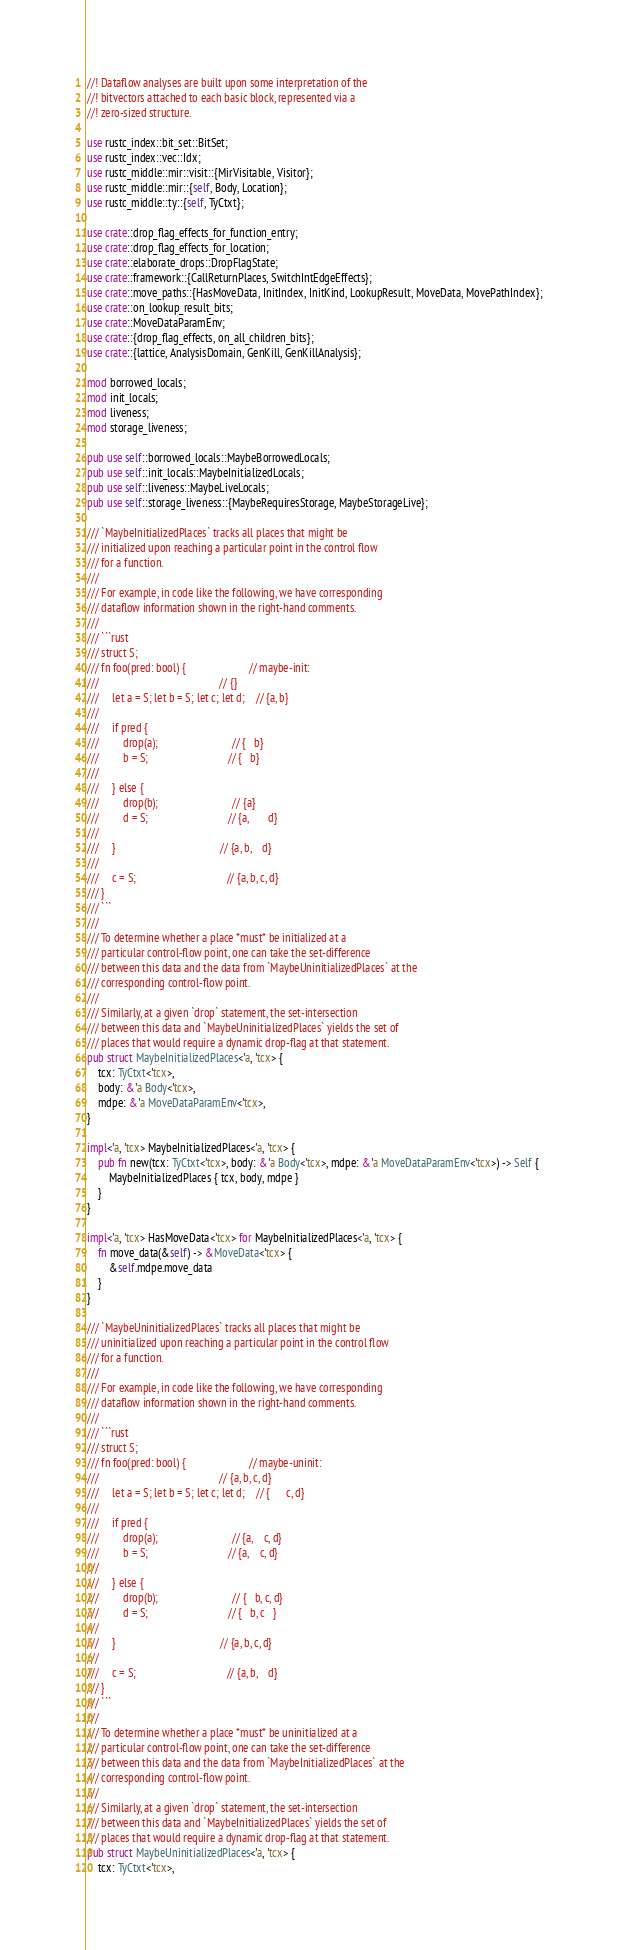<code> <loc_0><loc_0><loc_500><loc_500><_Rust_>//! Dataflow analyses are built upon some interpretation of the
//! bitvectors attached to each basic block, represented via a
//! zero-sized structure.

use rustc_index::bit_set::BitSet;
use rustc_index::vec::Idx;
use rustc_middle::mir::visit::{MirVisitable, Visitor};
use rustc_middle::mir::{self, Body, Location};
use rustc_middle::ty::{self, TyCtxt};

use crate::drop_flag_effects_for_function_entry;
use crate::drop_flag_effects_for_location;
use crate::elaborate_drops::DropFlagState;
use crate::framework::{CallReturnPlaces, SwitchIntEdgeEffects};
use crate::move_paths::{HasMoveData, InitIndex, InitKind, LookupResult, MoveData, MovePathIndex};
use crate::on_lookup_result_bits;
use crate::MoveDataParamEnv;
use crate::{drop_flag_effects, on_all_children_bits};
use crate::{lattice, AnalysisDomain, GenKill, GenKillAnalysis};

mod borrowed_locals;
mod init_locals;
mod liveness;
mod storage_liveness;

pub use self::borrowed_locals::MaybeBorrowedLocals;
pub use self::init_locals::MaybeInitializedLocals;
pub use self::liveness::MaybeLiveLocals;
pub use self::storage_liveness::{MaybeRequiresStorage, MaybeStorageLive};

/// `MaybeInitializedPlaces` tracks all places that might be
/// initialized upon reaching a particular point in the control flow
/// for a function.
///
/// For example, in code like the following, we have corresponding
/// dataflow information shown in the right-hand comments.
///
/// ```rust
/// struct S;
/// fn foo(pred: bool) {                       // maybe-init:
///                                            // {}
///     let a = S; let b = S; let c; let d;    // {a, b}
///
///     if pred {
///         drop(a);                           // {   b}
///         b = S;                             // {   b}
///
///     } else {
///         drop(b);                           // {a}
///         d = S;                             // {a,       d}
///
///     }                                      // {a, b,    d}
///
///     c = S;                                 // {a, b, c, d}
/// }
/// ```
///
/// To determine whether a place *must* be initialized at a
/// particular control-flow point, one can take the set-difference
/// between this data and the data from `MaybeUninitializedPlaces` at the
/// corresponding control-flow point.
///
/// Similarly, at a given `drop` statement, the set-intersection
/// between this data and `MaybeUninitializedPlaces` yields the set of
/// places that would require a dynamic drop-flag at that statement.
pub struct MaybeInitializedPlaces<'a, 'tcx> {
    tcx: TyCtxt<'tcx>,
    body: &'a Body<'tcx>,
    mdpe: &'a MoveDataParamEnv<'tcx>,
}

impl<'a, 'tcx> MaybeInitializedPlaces<'a, 'tcx> {
    pub fn new(tcx: TyCtxt<'tcx>, body: &'a Body<'tcx>, mdpe: &'a MoveDataParamEnv<'tcx>) -> Self {
        MaybeInitializedPlaces { tcx, body, mdpe }
    }
}

impl<'a, 'tcx> HasMoveData<'tcx> for MaybeInitializedPlaces<'a, 'tcx> {
    fn move_data(&self) -> &MoveData<'tcx> {
        &self.mdpe.move_data
    }
}

/// `MaybeUninitializedPlaces` tracks all places that might be
/// uninitialized upon reaching a particular point in the control flow
/// for a function.
///
/// For example, in code like the following, we have corresponding
/// dataflow information shown in the right-hand comments.
///
/// ```rust
/// struct S;
/// fn foo(pred: bool) {                       // maybe-uninit:
///                                            // {a, b, c, d}
///     let a = S; let b = S; let c; let d;    // {      c, d}
///
///     if pred {
///         drop(a);                           // {a,    c, d}
///         b = S;                             // {a,    c, d}
///
///     } else {
///         drop(b);                           // {   b, c, d}
///         d = S;                             // {   b, c   }
///
///     }                                      // {a, b, c, d}
///
///     c = S;                                 // {a, b,    d}
/// }
/// ```
///
/// To determine whether a place *must* be uninitialized at a
/// particular control-flow point, one can take the set-difference
/// between this data and the data from `MaybeInitializedPlaces` at the
/// corresponding control-flow point.
///
/// Similarly, at a given `drop` statement, the set-intersection
/// between this data and `MaybeInitializedPlaces` yields the set of
/// places that would require a dynamic drop-flag at that statement.
pub struct MaybeUninitializedPlaces<'a, 'tcx> {
    tcx: TyCtxt<'tcx>,</code> 